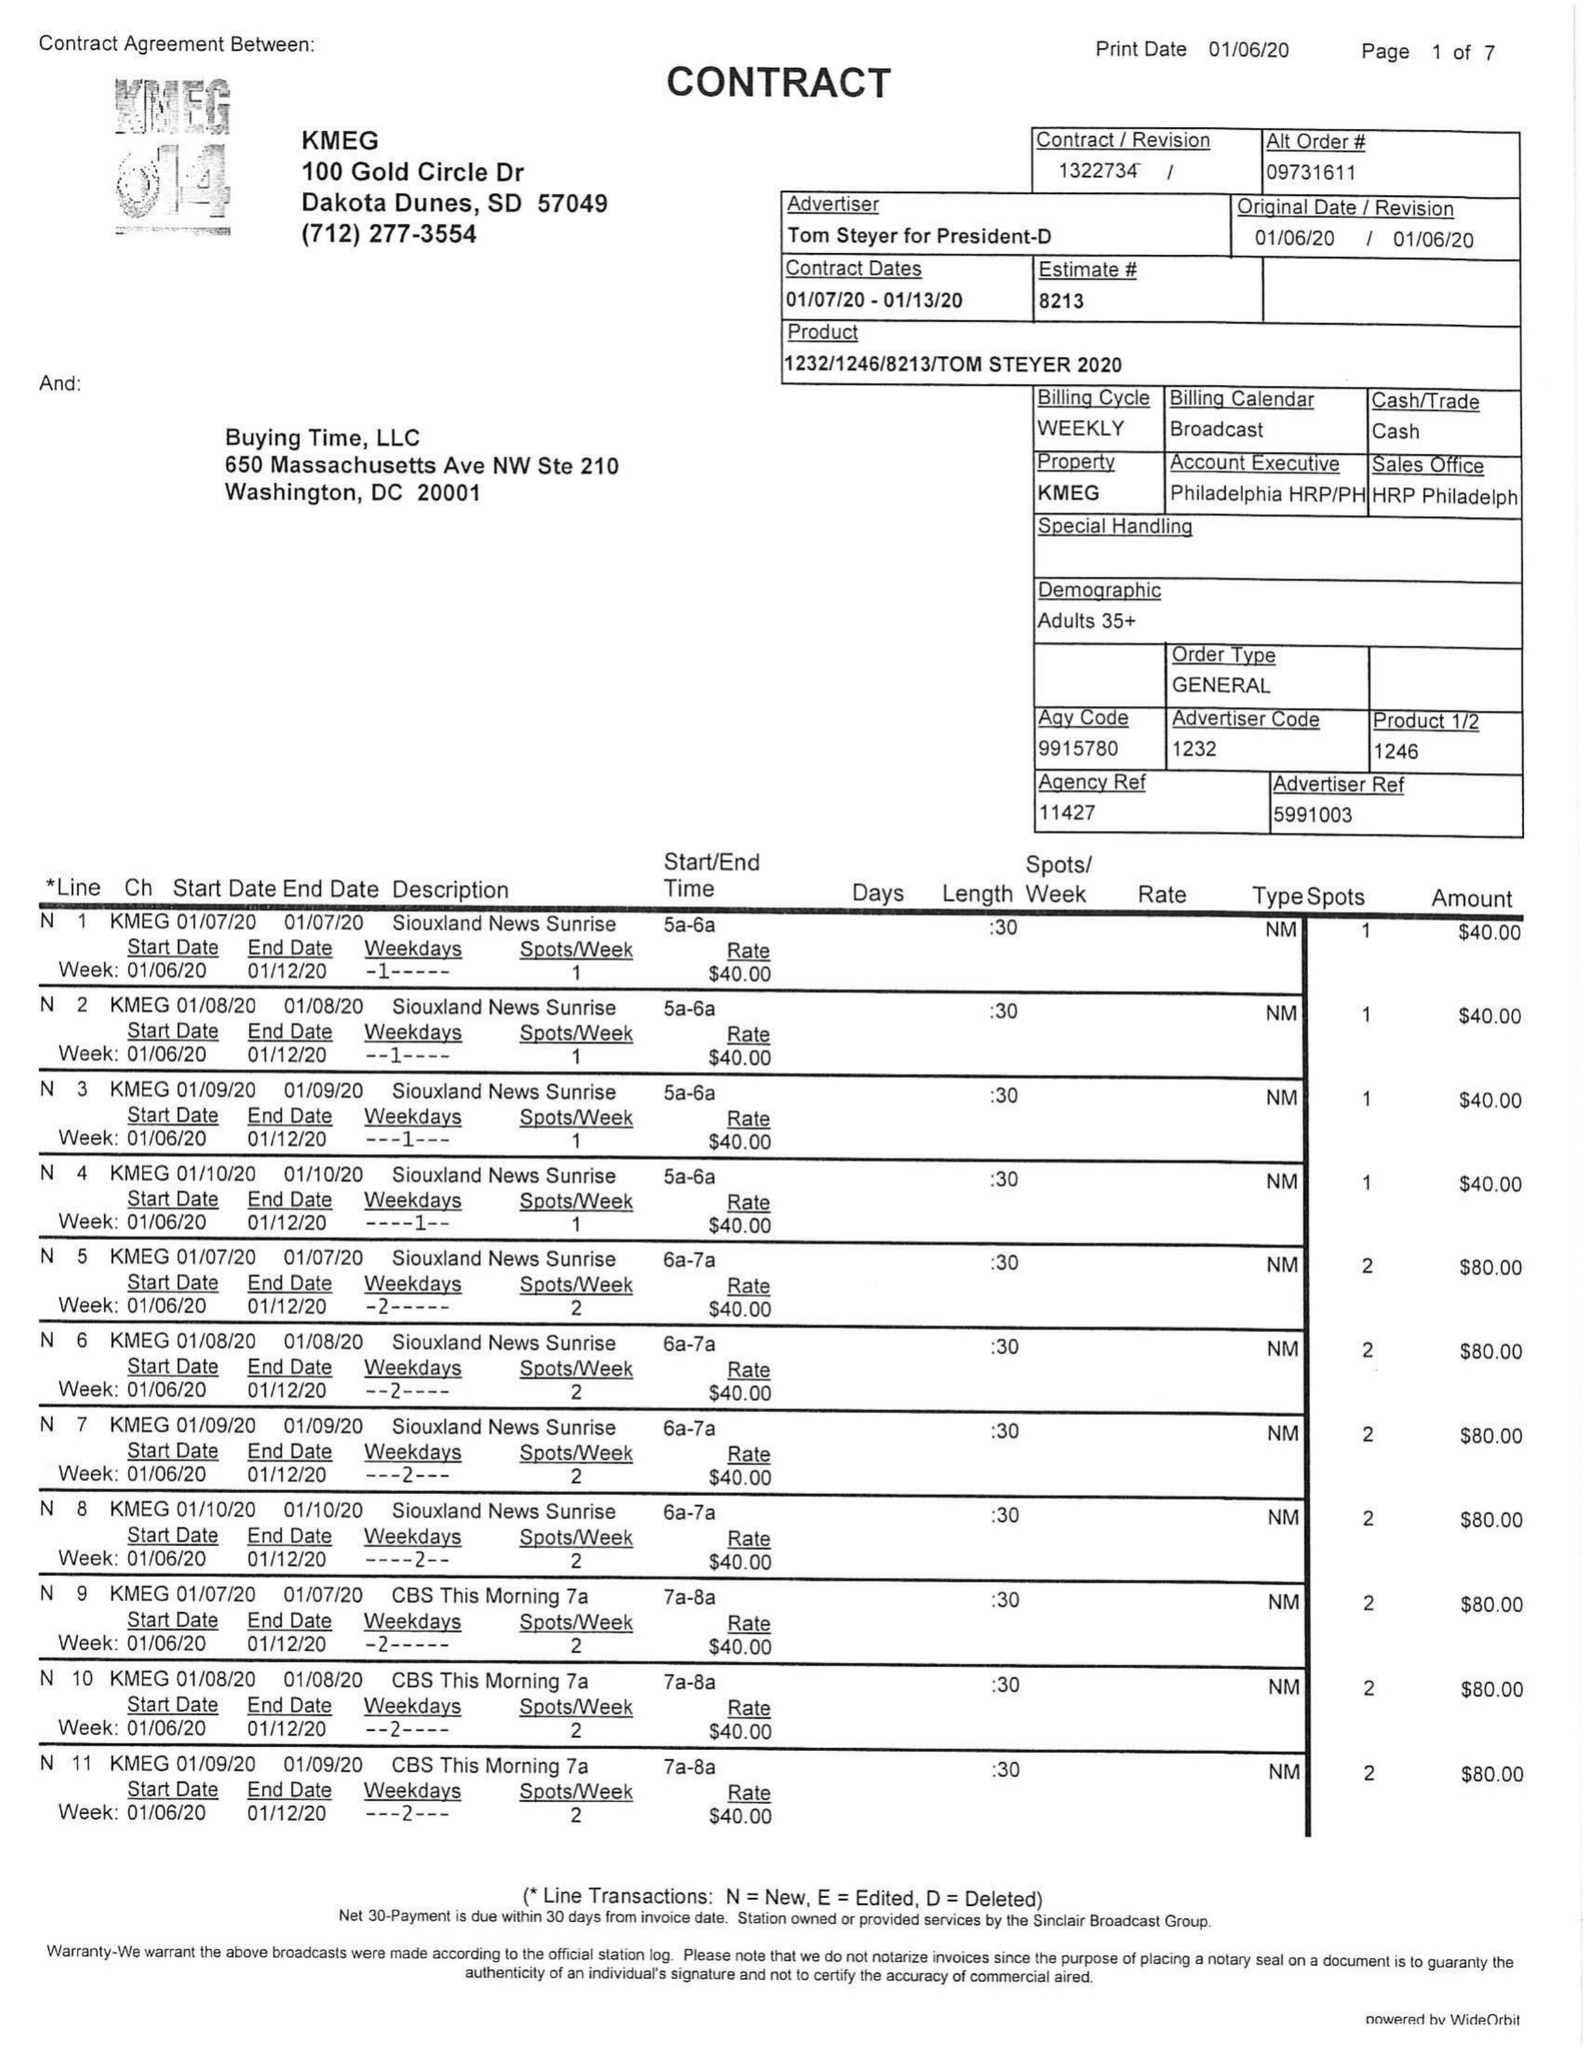What is the value for the advertiser?
Answer the question using a single word or phrase. TOM STEYER FOR PRESIDENT-D 